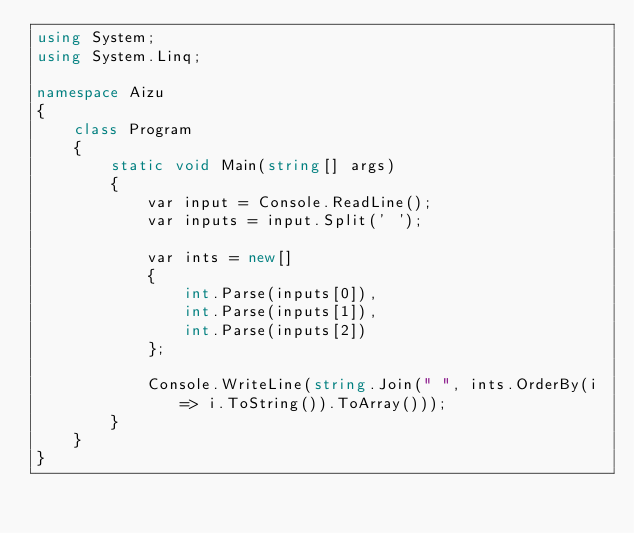<code> <loc_0><loc_0><loc_500><loc_500><_C#_>using System;
using System.Linq;

namespace Aizu
{
    class Program
    {
        static void Main(string[] args)
        {
            var input = Console.ReadLine();
            var inputs = input.Split(' ');

            var ints = new[]
            {
                int.Parse(inputs[0]),
                int.Parse(inputs[1]),
                int.Parse(inputs[2])
            };

            Console.WriteLine(string.Join(" ", ints.OrderBy(i => i.ToString()).ToArray()));
        }
    }
}</code> 